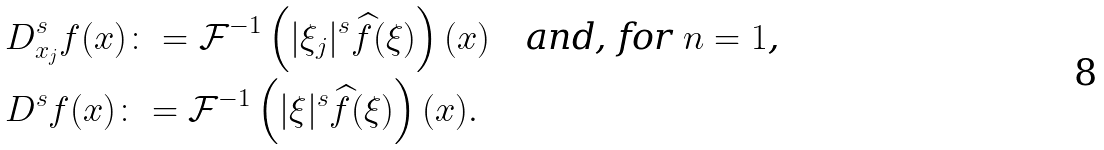<formula> <loc_0><loc_0><loc_500><loc_500>& D ^ { s } _ { x _ { j } } f ( x ) \colon = \mathcal { F } ^ { - 1 } \left ( | \xi _ { j } | ^ { s } \widehat { f } ( \xi ) \right ) ( x ) \quad \text {and, for $n=1$,} \\ & D ^ { s } f ( x ) \colon = \mathcal { F } ^ { - 1 } \left ( | \xi | ^ { s } \widehat { f } ( \xi ) \right ) ( x ) .</formula> 